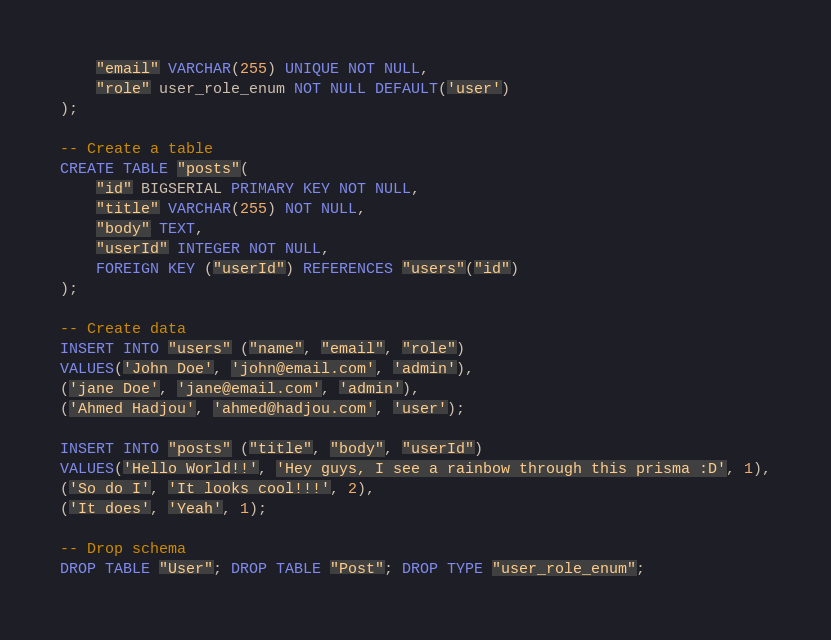<code> <loc_0><loc_0><loc_500><loc_500><_SQL_>    "email" VARCHAR(255) UNIQUE NOT NULL,
    "role" user_role_enum NOT NULL DEFAULT('user')
);

-- Create a table
CREATE TABLE "posts"(
    "id" BIGSERIAL PRIMARY KEY NOT NULL,
    "title" VARCHAR(255) NOT NULL,
    "body" TEXT,
    "userId" INTEGER NOT NULL,
    FOREIGN KEY ("userId") REFERENCES "users"("id")
);

-- Create data
INSERT INTO "users" ("name", "email", "role")
VALUES('John Doe', 'john@email.com', 'admin'),
('jane Doe', 'jane@email.com', 'admin'),
('Ahmed Hadjou', 'ahmed@hadjou.com', 'user');

INSERT INTO "posts" ("title", "body", "userId")
VALUES('Hello World!!', 'Hey guys, I see a rainbow through this prisma :D', 1),
('So do I', 'It looks cool!!!', 2),
('It does', 'Yeah', 1);

-- Drop schema
DROP TABLE "User"; DROP TABLE "Post"; DROP TYPE "user_role_enum";</code> 